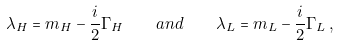Convert formula to latex. <formula><loc_0><loc_0><loc_500><loc_500>\lambda _ { H } = m _ { H } - \frac { i } { 2 } \Gamma _ { H } \quad a n d \quad \lambda _ { L } = m _ { L } - \frac { i } { 2 } \Gamma _ { L } \, ,</formula> 